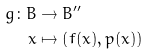Convert formula to latex. <formula><loc_0><loc_0><loc_500><loc_500>g \colon B & \to B ^ { \prime \prime } \\ x & \mapsto \left ( f ( x ) , p ( x ) \right )</formula> 